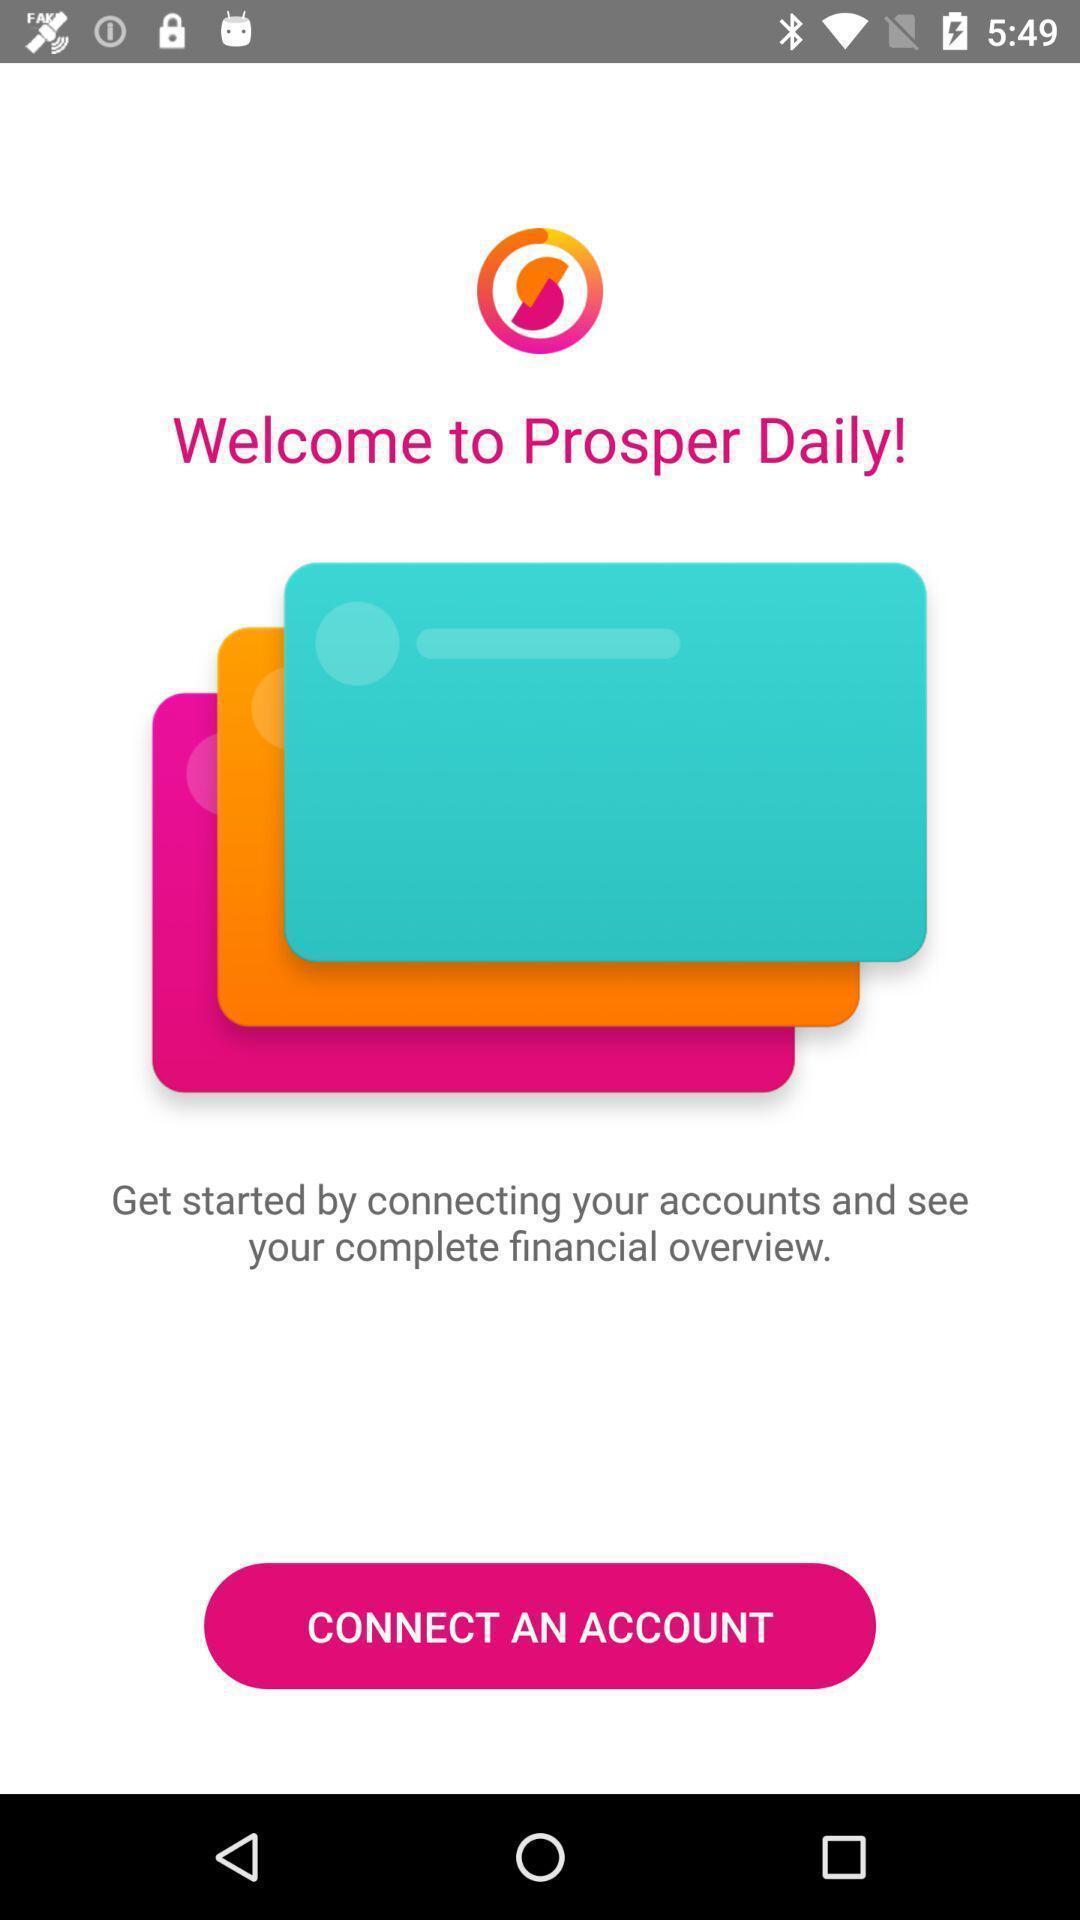What is the overall content of this screenshot? Welcome page. 